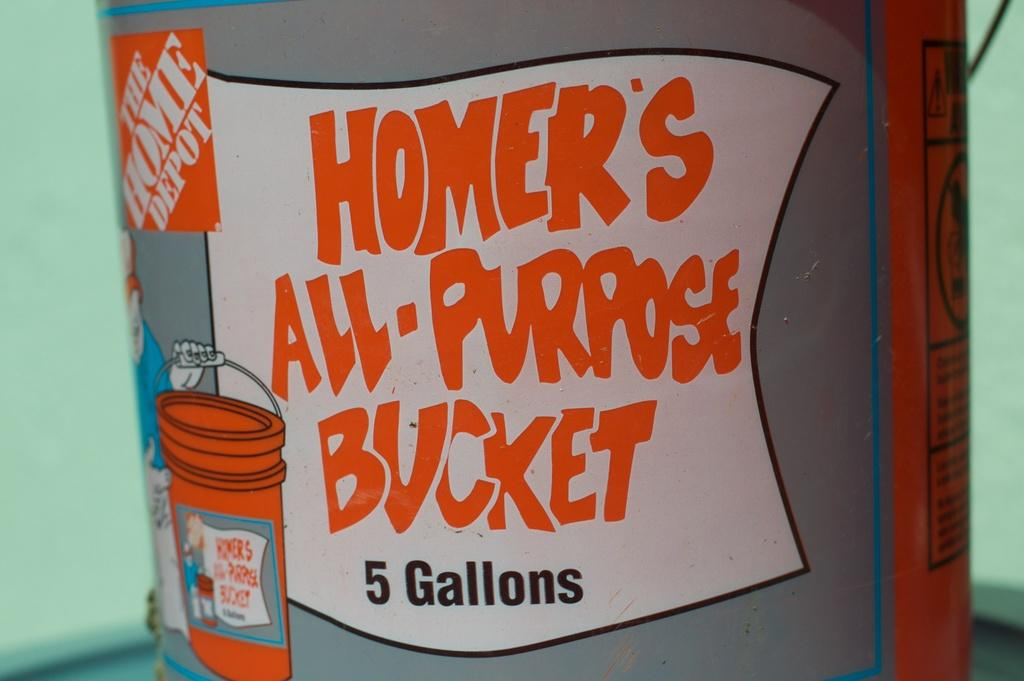<image>
Describe the image concisely. Homer's All-Purpose Bucket is available in the 5 gallon size. 